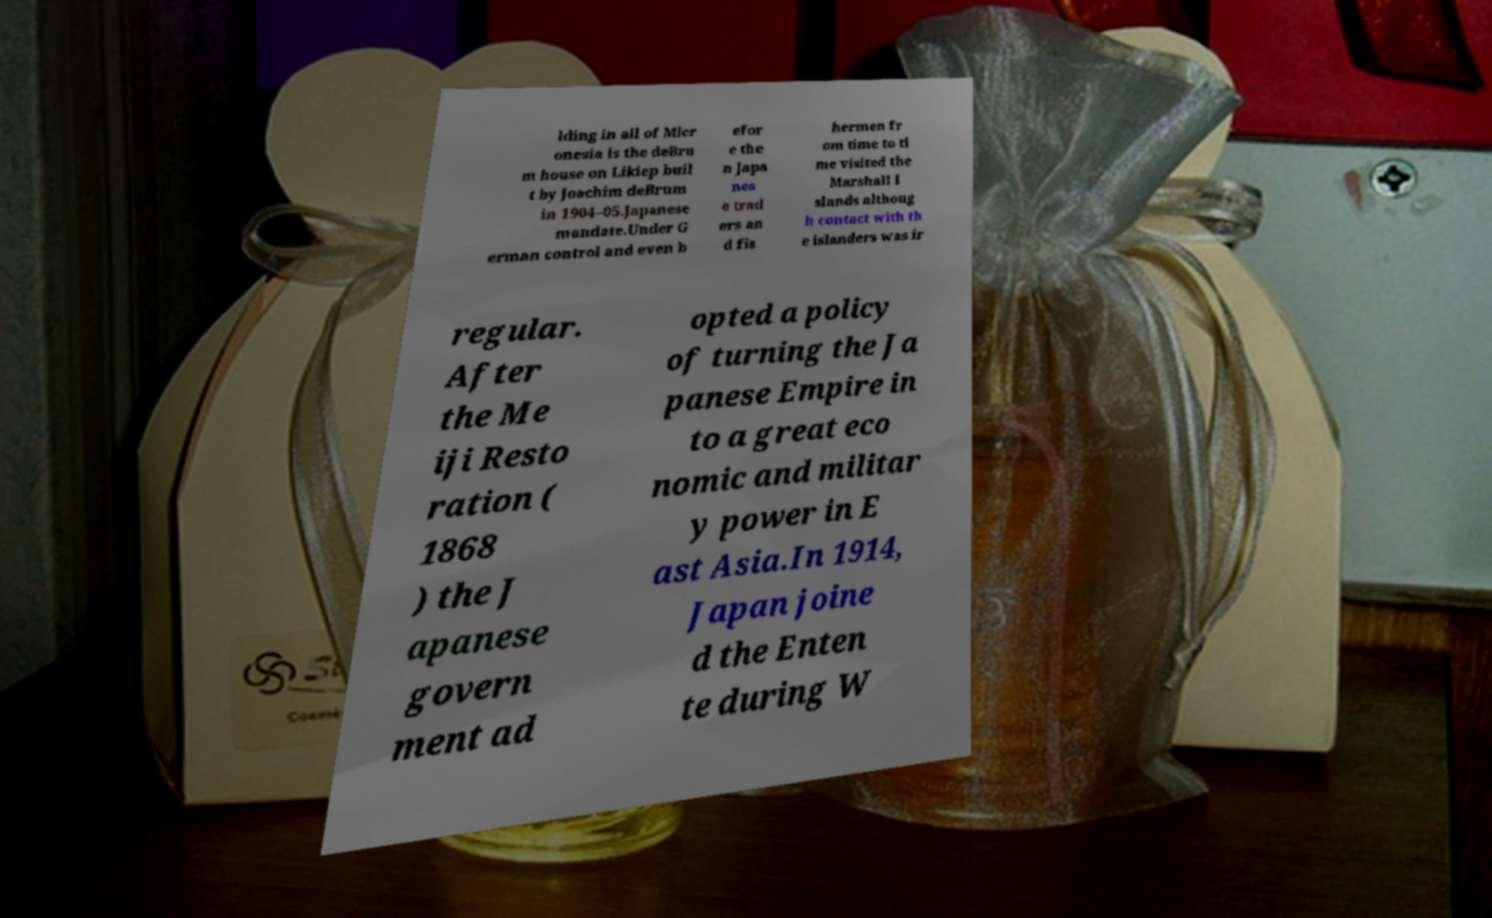I need the written content from this picture converted into text. Can you do that? lding in all of Micr onesia is the deBru m house on Likiep buil t by Joachim deBrum in 1904–05.Japanese mandate.Under G erman control and even b efor e the n Japa nes e trad ers an d fis hermen fr om time to ti me visited the Marshall I slands althoug h contact with th e islanders was ir regular. After the Me iji Resto ration ( 1868 ) the J apanese govern ment ad opted a policy of turning the Ja panese Empire in to a great eco nomic and militar y power in E ast Asia.In 1914, Japan joine d the Enten te during W 